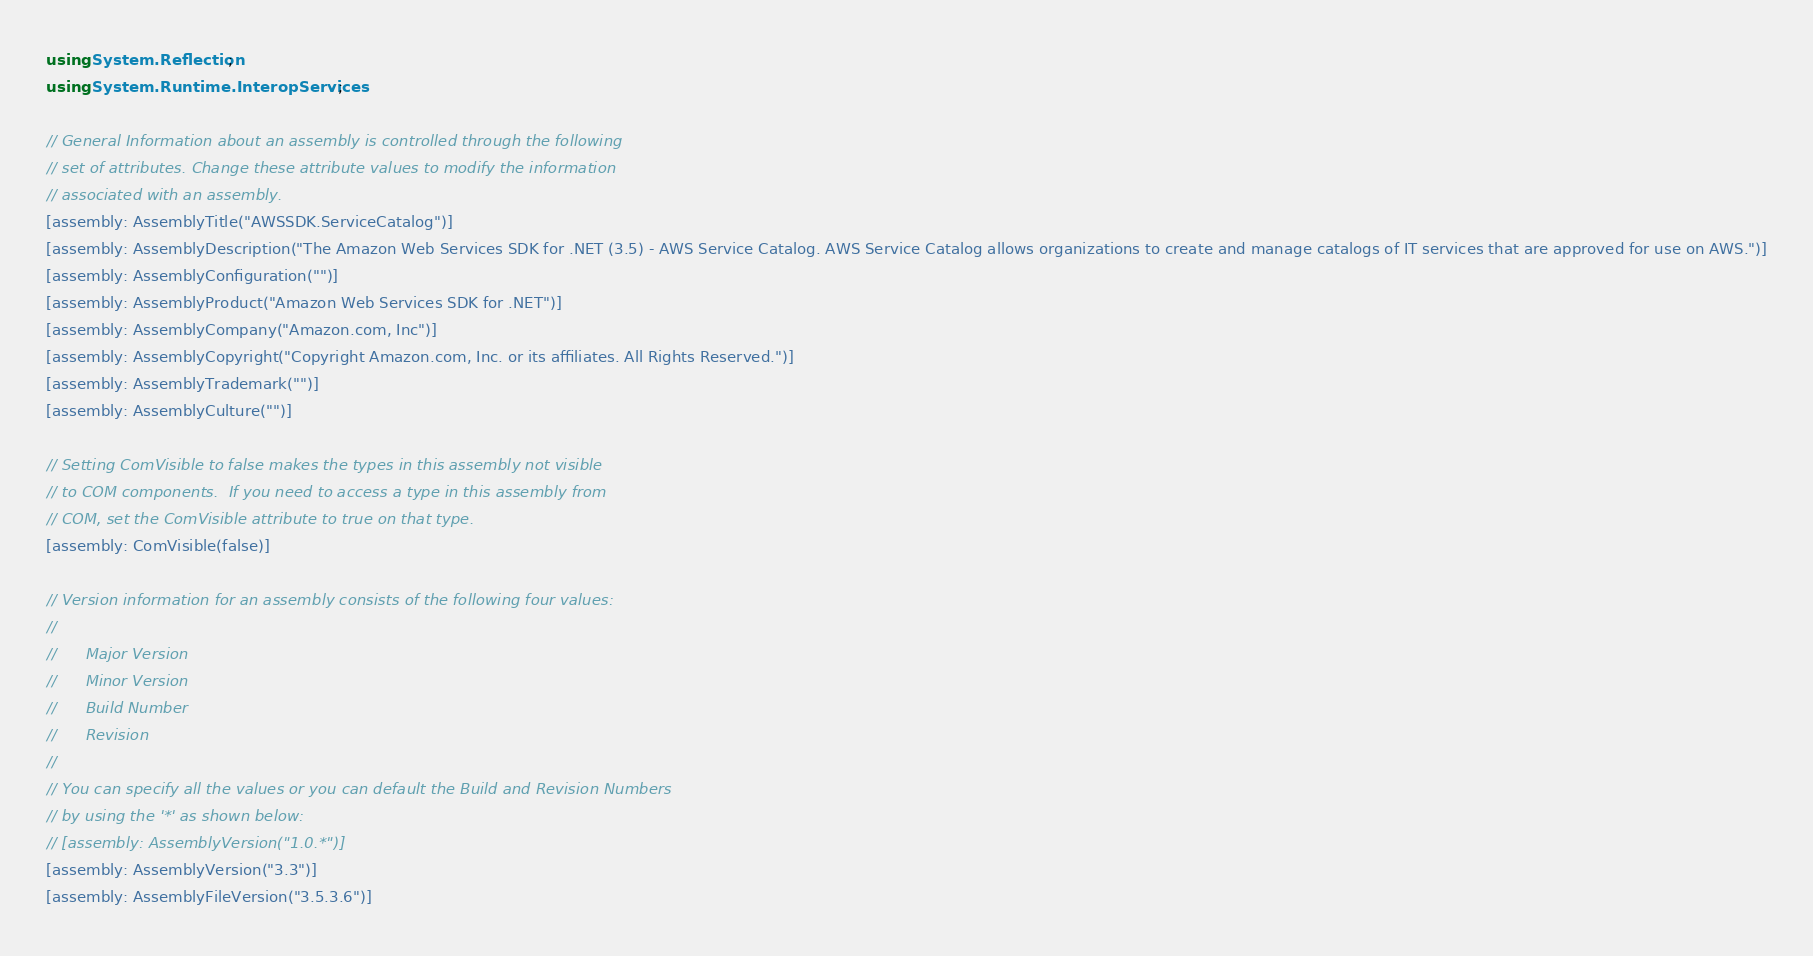Convert code to text. <code><loc_0><loc_0><loc_500><loc_500><_C#_>using System.Reflection;
using System.Runtime.InteropServices;

// General Information about an assembly is controlled through the following 
// set of attributes. Change these attribute values to modify the information
// associated with an assembly.
[assembly: AssemblyTitle("AWSSDK.ServiceCatalog")]
[assembly: AssemblyDescription("The Amazon Web Services SDK for .NET (3.5) - AWS Service Catalog. AWS Service Catalog allows organizations to create and manage catalogs of IT services that are approved for use on AWS.")]
[assembly: AssemblyConfiguration("")]
[assembly: AssemblyProduct("Amazon Web Services SDK for .NET")]
[assembly: AssemblyCompany("Amazon.com, Inc")]
[assembly: AssemblyCopyright("Copyright Amazon.com, Inc. or its affiliates. All Rights Reserved.")]
[assembly: AssemblyTrademark("")]
[assembly: AssemblyCulture("")]

// Setting ComVisible to false makes the types in this assembly not visible 
// to COM components.  If you need to access a type in this assembly from 
// COM, set the ComVisible attribute to true on that type.
[assembly: ComVisible(false)]

// Version information for an assembly consists of the following four values:
//
//      Major Version
//      Minor Version 
//      Build Number
//      Revision
//
// You can specify all the values or you can default the Build and Revision Numbers 
// by using the '*' as shown below:
// [assembly: AssemblyVersion("1.0.*")]
[assembly: AssemblyVersion("3.3")]
[assembly: AssemblyFileVersion("3.5.3.6")]</code> 